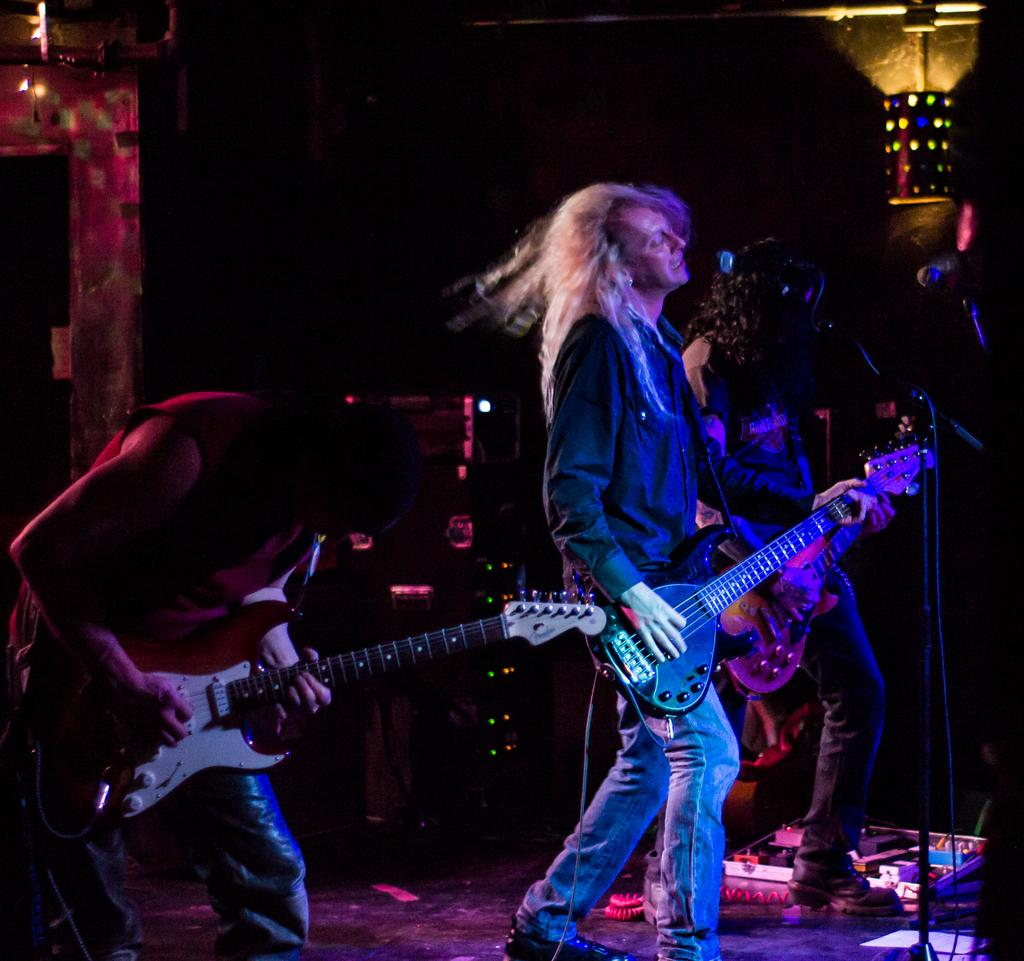What are the people in the image doing? The people in the image are standing and holding a guitar. What object is in front of one of the people? There is a microphone in front of one of the people. What can be seen in the background of the image? There is a light in the background of the image. What type of cracker is being used as a drumstick in the image? There is no cracker or drumstick present in the image; the people are holding a guitar and standing near a microphone. 